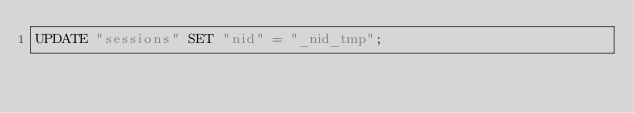<code> <loc_0><loc_0><loc_500><loc_500><_SQL_>UPDATE "sessions" SET "nid" = "_nid_tmp";</code> 